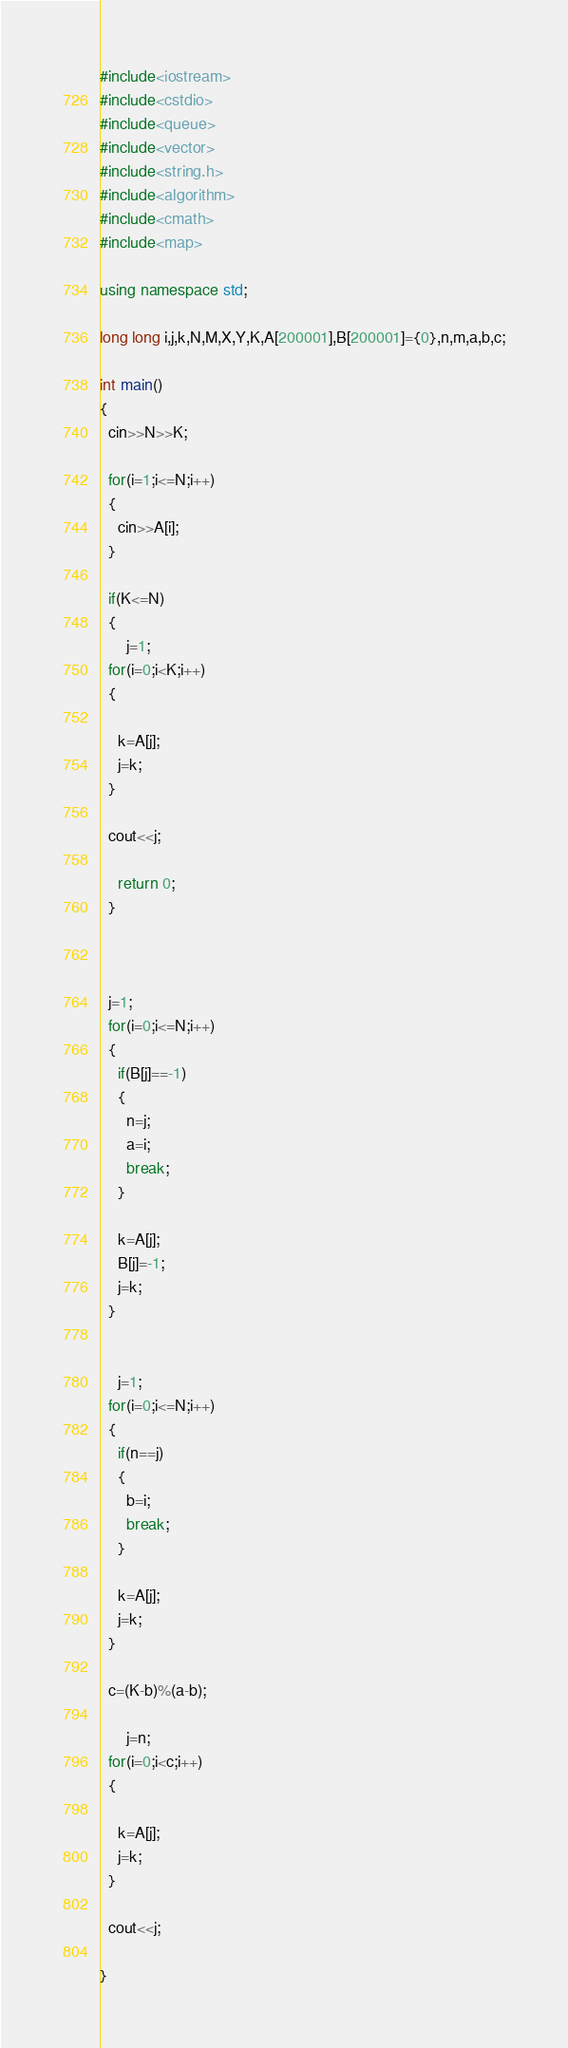Convert code to text. <code><loc_0><loc_0><loc_500><loc_500><_C++_>#include<iostream>
#include<cstdio>
#include<queue>
#include<vector>
#include<string.h>
#include<algorithm>
#include<cmath>
#include<map>

using namespace std;

long long i,j,k,N,M,X,Y,K,A[200001],B[200001]={0},n,m,a,b,c;

int main()
{
  cin>>N>>K;
  
  for(i=1;i<=N;i++)
  {
    cin>>A[i];
  }
  
  if(K<=N)
  {
      j=1;
  for(i=0;i<K;i++)
  {
    
    k=A[j];
    j=k;
  }
  
  cout<<j;
    
    return 0;
  }
  
  
  
  j=1;
  for(i=0;i<=N;i++)
  {
    if(B[j]==-1)
    {
      n=j;
      a=i;
      break;
    }
    
    k=A[j];
    B[j]=-1;
    j=k;
  }
  
  
    j=1;
  for(i=0;i<=N;i++)
  {
    if(n==j)
    {
      b=i;
      break;
    }
    
    k=A[j];
    j=k;
  }
  
  c=(K-b)%(a-b);
  
      j=n;
  for(i=0;i<c;i++)
  {
    
    k=A[j];
    j=k;
  }
  
  cout<<j;
  
}</code> 